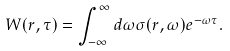Convert formula to latex. <formula><loc_0><loc_0><loc_500><loc_500>W ( r , \tau ) = \int _ { - \infty } ^ { \infty } d \omega \sigma ( r , \omega ) e ^ { - \omega \tau } .</formula> 